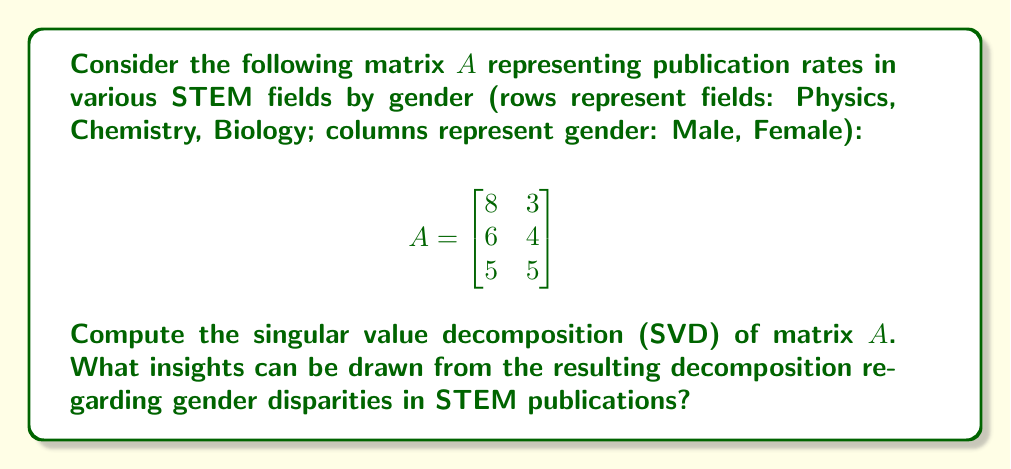Show me your answer to this math problem. To compute the singular value decomposition of matrix $A$, we need to find matrices $U$, $\Sigma$, and $V^T$ such that $A = U\Sigma V^T$. Let's follow these steps:

1) First, calculate $A^TA$ and $AA^T$:

   $$A^TA = \begin{bmatrix}
   8 & 6 & 5 \\
   3 & 4 & 5
   \end{bmatrix} \begin{bmatrix}
   8 & 3 \\
   6 & 4 \\
   5 & 5
   \end{bmatrix} = \begin{bmatrix}
   125 & 74 \\
   74 & 50
   \end{bmatrix}$$

   $$AA^T = \begin{bmatrix}
   8 & 3 \\
   6 & 4 \\
   5 & 5
   \end{bmatrix} \begin{bmatrix}
   8 & 6 & 5 \\
   3 & 4 & 5
   \end{bmatrix} = \begin{bmatrix}
   73 & 54 & 55 \\
   54 & 52 & 50 \\
   55 & 50 & 50
   \end{bmatrix}$$

2) Find eigenvalues of $A^TA$ (which are the squares of singular values):
   
   $det(A^TA - \lambda I) = \begin{vmatrix}
   125-\lambda & 74 \\
   74 & 50-\lambda
   \end{vmatrix} = (125-\lambda)(50-\lambda) - 74^2 = 0$

   $\lambda^2 - 175\lambda + 1475 = 0$
   
   Solving this quadratic equation gives: $\lambda_1 \approx 170.05$ and $\lambda_2 \approx 4.95$

3) The singular values are the square roots of these eigenvalues:
   
   $\sigma_1 \approx \sqrt{170.05} \approx 13.04$ and $\sigma_2 \approx \sqrt{4.95} \approx 2.22$

4) Find the right singular vectors (eigenvectors of $A^TA$):
   
   For $\lambda_1 \approx 170.05$:
   $\begin{bmatrix}
   -45.05 & 74 \\
   74 & -120.05
   \end{bmatrix} \begin{bmatrix}
   x_1 \\
   x_2
   \end{bmatrix} = \begin{bmatrix}
   0 \\
   0
   \end{bmatrix}$

   Solving this gives $v_1 \approx [0.86, 0.51]^T$

   Similarly, for $\lambda_2$, we get $v_2 \approx [-0.51, 0.86]^T$

5) Find the left singular vectors (eigenvectors of $AA^T$):
   
   $u_1 = \frac{1}{\sigma_1}Av_1 \approx [0.65, 0.54, 0.53]^T$
   
   $u_2 = \frac{1}{\sigma_2}Av_2 \approx [-0.23, 0.32, 0.92]^T$
   
   The third left singular vector $u_3$ is orthogonal to $u_1$ and $u_2$.

6) The SVD of $A$ is therefore:

   $$A \approx \begin{bmatrix}
   0.65 & -0.23 & 0.73 \\
   0.54 & 0.32 & -0.78 \\
   0.53 & 0.92 & 0.02
   \end{bmatrix} \begin{bmatrix}
   13.04 & 0 \\
   0 & 2.22 \\
   0 & 0
   \end{bmatrix} \begin{bmatrix}
   0.86 & -0.51 \\
   0.51 & 0.86
   \end{bmatrix}$$

Insights:
- The first singular value (13.04) is much larger than the second (2.22), indicating a dominant trend in the data.
- The first right singular vector [0.86, 0.51] suggests that this dominant trend is more aligned with the first column (male publication rates) than the second (female publication rates).
- The first left singular vector [0.65, 0.54, 0.53] shows that this trend is relatively uniform across all three fields.
- The second singular value and its corresponding vectors represent a smaller, secondary trend that captures the differences between fields and genders.

These insights reveal a clear gender disparity in publication rates across STEM fields, with a dominant trend favoring male researchers. However, the secondary trend suggests some variation in this disparity across different fields.
Answer: The SVD of matrix $A$ is approximately:

$$A \approx \begin{bmatrix}
0.65 & -0.23 & 0.73 \\
0.54 & 0.32 & -0.78 \\
0.53 & 0.92 & 0.02
\end{bmatrix} \begin{bmatrix}
13.04 & 0 \\
0 & 2.22 \\
0 & 0
\end{bmatrix} \begin{bmatrix}
0.86 & -0.51 \\
0.51 & 0.86
\end{bmatrix}$$

This decomposition reveals a significant gender disparity in STEM publication rates, with a dominant trend favoring male researchers across all fields, and a smaller secondary trend capturing field-specific variations in this disparity. 